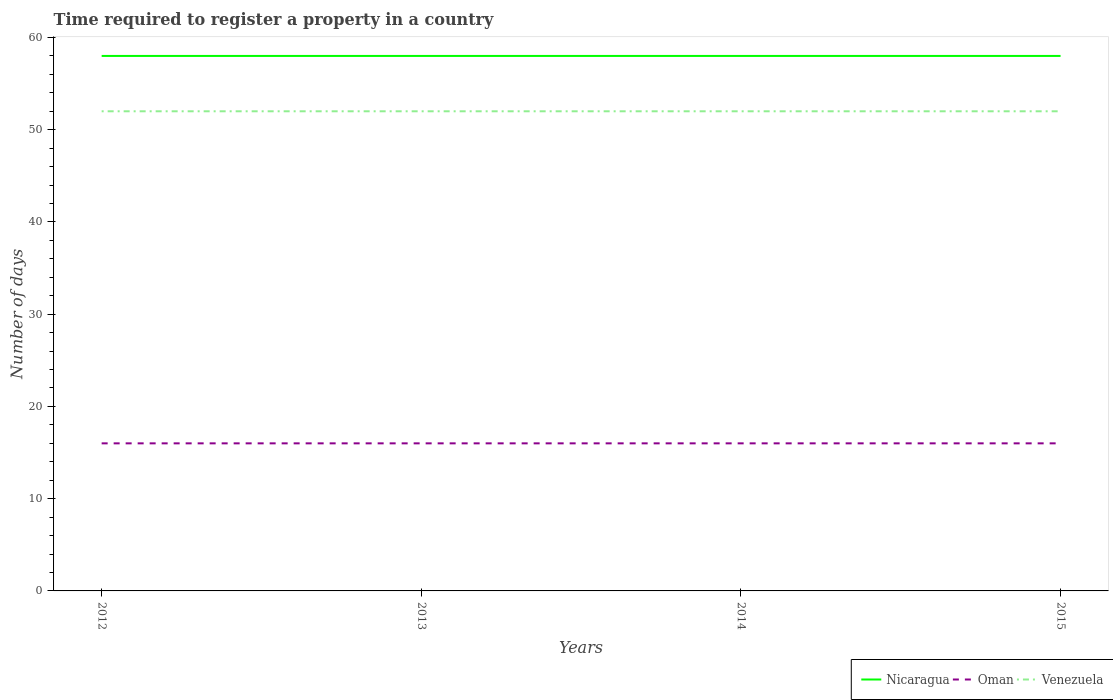How many different coloured lines are there?
Your answer should be very brief. 3. Does the line corresponding to Venezuela intersect with the line corresponding to Oman?
Give a very brief answer. No. Is the number of lines equal to the number of legend labels?
Your response must be concise. Yes. Across all years, what is the maximum number of days required to register a property in Oman?
Your response must be concise. 16. In which year was the number of days required to register a property in Nicaragua maximum?
Offer a terse response. 2012. What is the total number of days required to register a property in Oman in the graph?
Provide a short and direct response. 0. What is the difference between the highest and the second highest number of days required to register a property in Nicaragua?
Ensure brevity in your answer.  0. Is the number of days required to register a property in Nicaragua strictly greater than the number of days required to register a property in Venezuela over the years?
Give a very brief answer. No. How many lines are there?
Your response must be concise. 3. How many years are there in the graph?
Your answer should be very brief. 4. Does the graph contain any zero values?
Ensure brevity in your answer.  No. How many legend labels are there?
Ensure brevity in your answer.  3. What is the title of the graph?
Your response must be concise. Time required to register a property in a country. Does "High income" appear as one of the legend labels in the graph?
Give a very brief answer. No. What is the label or title of the Y-axis?
Provide a succinct answer. Number of days. What is the Number of days in Nicaragua in 2012?
Keep it short and to the point. 58. What is the Number of days in Oman in 2012?
Offer a very short reply. 16. What is the Number of days in Oman in 2013?
Your answer should be very brief. 16. What is the Number of days in Nicaragua in 2014?
Your response must be concise. 58. What is the Number of days in Oman in 2014?
Offer a terse response. 16. What is the Number of days in Oman in 2015?
Your answer should be compact. 16. What is the Number of days of Venezuela in 2015?
Offer a terse response. 52. Across all years, what is the maximum Number of days of Nicaragua?
Offer a terse response. 58. Across all years, what is the maximum Number of days of Oman?
Your answer should be compact. 16. Across all years, what is the maximum Number of days of Venezuela?
Keep it short and to the point. 52. Across all years, what is the minimum Number of days of Nicaragua?
Provide a succinct answer. 58. Across all years, what is the minimum Number of days in Oman?
Give a very brief answer. 16. Across all years, what is the minimum Number of days in Venezuela?
Provide a short and direct response. 52. What is the total Number of days in Nicaragua in the graph?
Offer a terse response. 232. What is the total Number of days of Venezuela in the graph?
Give a very brief answer. 208. What is the difference between the Number of days of Nicaragua in 2012 and that in 2013?
Your answer should be very brief. 0. What is the difference between the Number of days in Oman in 2012 and that in 2014?
Your answer should be very brief. 0. What is the difference between the Number of days of Nicaragua in 2012 and that in 2015?
Provide a short and direct response. 0. What is the difference between the Number of days in Oman in 2012 and that in 2015?
Provide a succinct answer. 0. What is the difference between the Number of days in Nicaragua in 2013 and that in 2014?
Give a very brief answer. 0. What is the difference between the Number of days in Oman in 2013 and that in 2014?
Your response must be concise. 0. What is the difference between the Number of days of Oman in 2013 and that in 2015?
Offer a terse response. 0. What is the difference between the Number of days in Nicaragua in 2014 and that in 2015?
Keep it short and to the point. 0. What is the difference between the Number of days in Venezuela in 2014 and that in 2015?
Ensure brevity in your answer.  0. What is the difference between the Number of days in Oman in 2012 and the Number of days in Venezuela in 2013?
Make the answer very short. -36. What is the difference between the Number of days of Nicaragua in 2012 and the Number of days of Oman in 2014?
Offer a terse response. 42. What is the difference between the Number of days in Oman in 2012 and the Number of days in Venezuela in 2014?
Give a very brief answer. -36. What is the difference between the Number of days of Nicaragua in 2012 and the Number of days of Venezuela in 2015?
Your answer should be compact. 6. What is the difference between the Number of days of Oman in 2012 and the Number of days of Venezuela in 2015?
Keep it short and to the point. -36. What is the difference between the Number of days of Oman in 2013 and the Number of days of Venezuela in 2014?
Provide a short and direct response. -36. What is the difference between the Number of days in Nicaragua in 2013 and the Number of days in Oman in 2015?
Keep it short and to the point. 42. What is the difference between the Number of days of Oman in 2013 and the Number of days of Venezuela in 2015?
Give a very brief answer. -36. What is the difference between the Number of days in Oman in 2014 and the Number of days in Venezuela in 2015?
Offer a very short reply. -36. What is the average Number of days in Nicaragua per year?
Give a very brief answer. 58. What is the average Number of days of Oman per year?
Your answer should be compact. 16. What is the average Number of days of Venezuela per year?
Give a very brief answer. 52. In the year 2012, what is the difference between the Number of days in Oman and Number of days in Venezuela?
Provide a short and direct response. -36. In the year 2013, what is the difference between the Number of days in Nicaragua and Number of days in Oman?
Provide a succinct answer. 42. In the year 2013, what is the difference between the Number of days in Nicaragua and Number of days in Venezuela?
Make the answer very short. 6. In the year 2013, what is the difference between the Number of days in Oman and Number of days in Venezuela?
Your response must be concise. -36. In the year 2014, what is the difference between the Number of days in Nicaragua and Number of days in Oman?
Give a very brief answer. 42. In the year 2014, what is the difference between the Number of days of Nicaragua and Number of days of Venezuela?
Ensure brevity in your answer.  6. In the year 2014, what is the difference between the Number of days in Oman and Number of days in Venezuela?
Give a very brief answer. -36. In the year 2015, what is the difference between the Number of days of Nicaragua and Number of days of Venezuela?
Your response must be concise. 6. In the year 2015, what is the difference between the Number of days in Oman and Number of days in Venezuela?
Your response must be concise. -36. What is the ratio of the Number of days in Nicaragua in 2012 to that in 2015?
Ensure brevity in your answer.  1. What is the ratio of the Number of days of Nicaragua in 2013 to that in 2015?
Provide a succinct answer. 1. What is the ratio of the Number of days of Oman in 2013 to that in 2015?
Your answer should be compact. 1. What is the ratio of the Number of days of Venezuela in 2013 to that in 2015?
Provide a succinct answer. 1. What is the ratio of the Number of days of Nicaragua in 2014 to that in 2015?
Provide a short and direct response. 1. What is the difference between the highest and the second highest Number of days in Venezuela?
Provide a succinct answer. 0. What is the difference between the highest and the lowest Number of days in Nicaragua?
Ensure brevity in your answer.  0. What is the difference between the highest and the lowest Number of days in Venezuela?
Your answer should be compact. 0. 